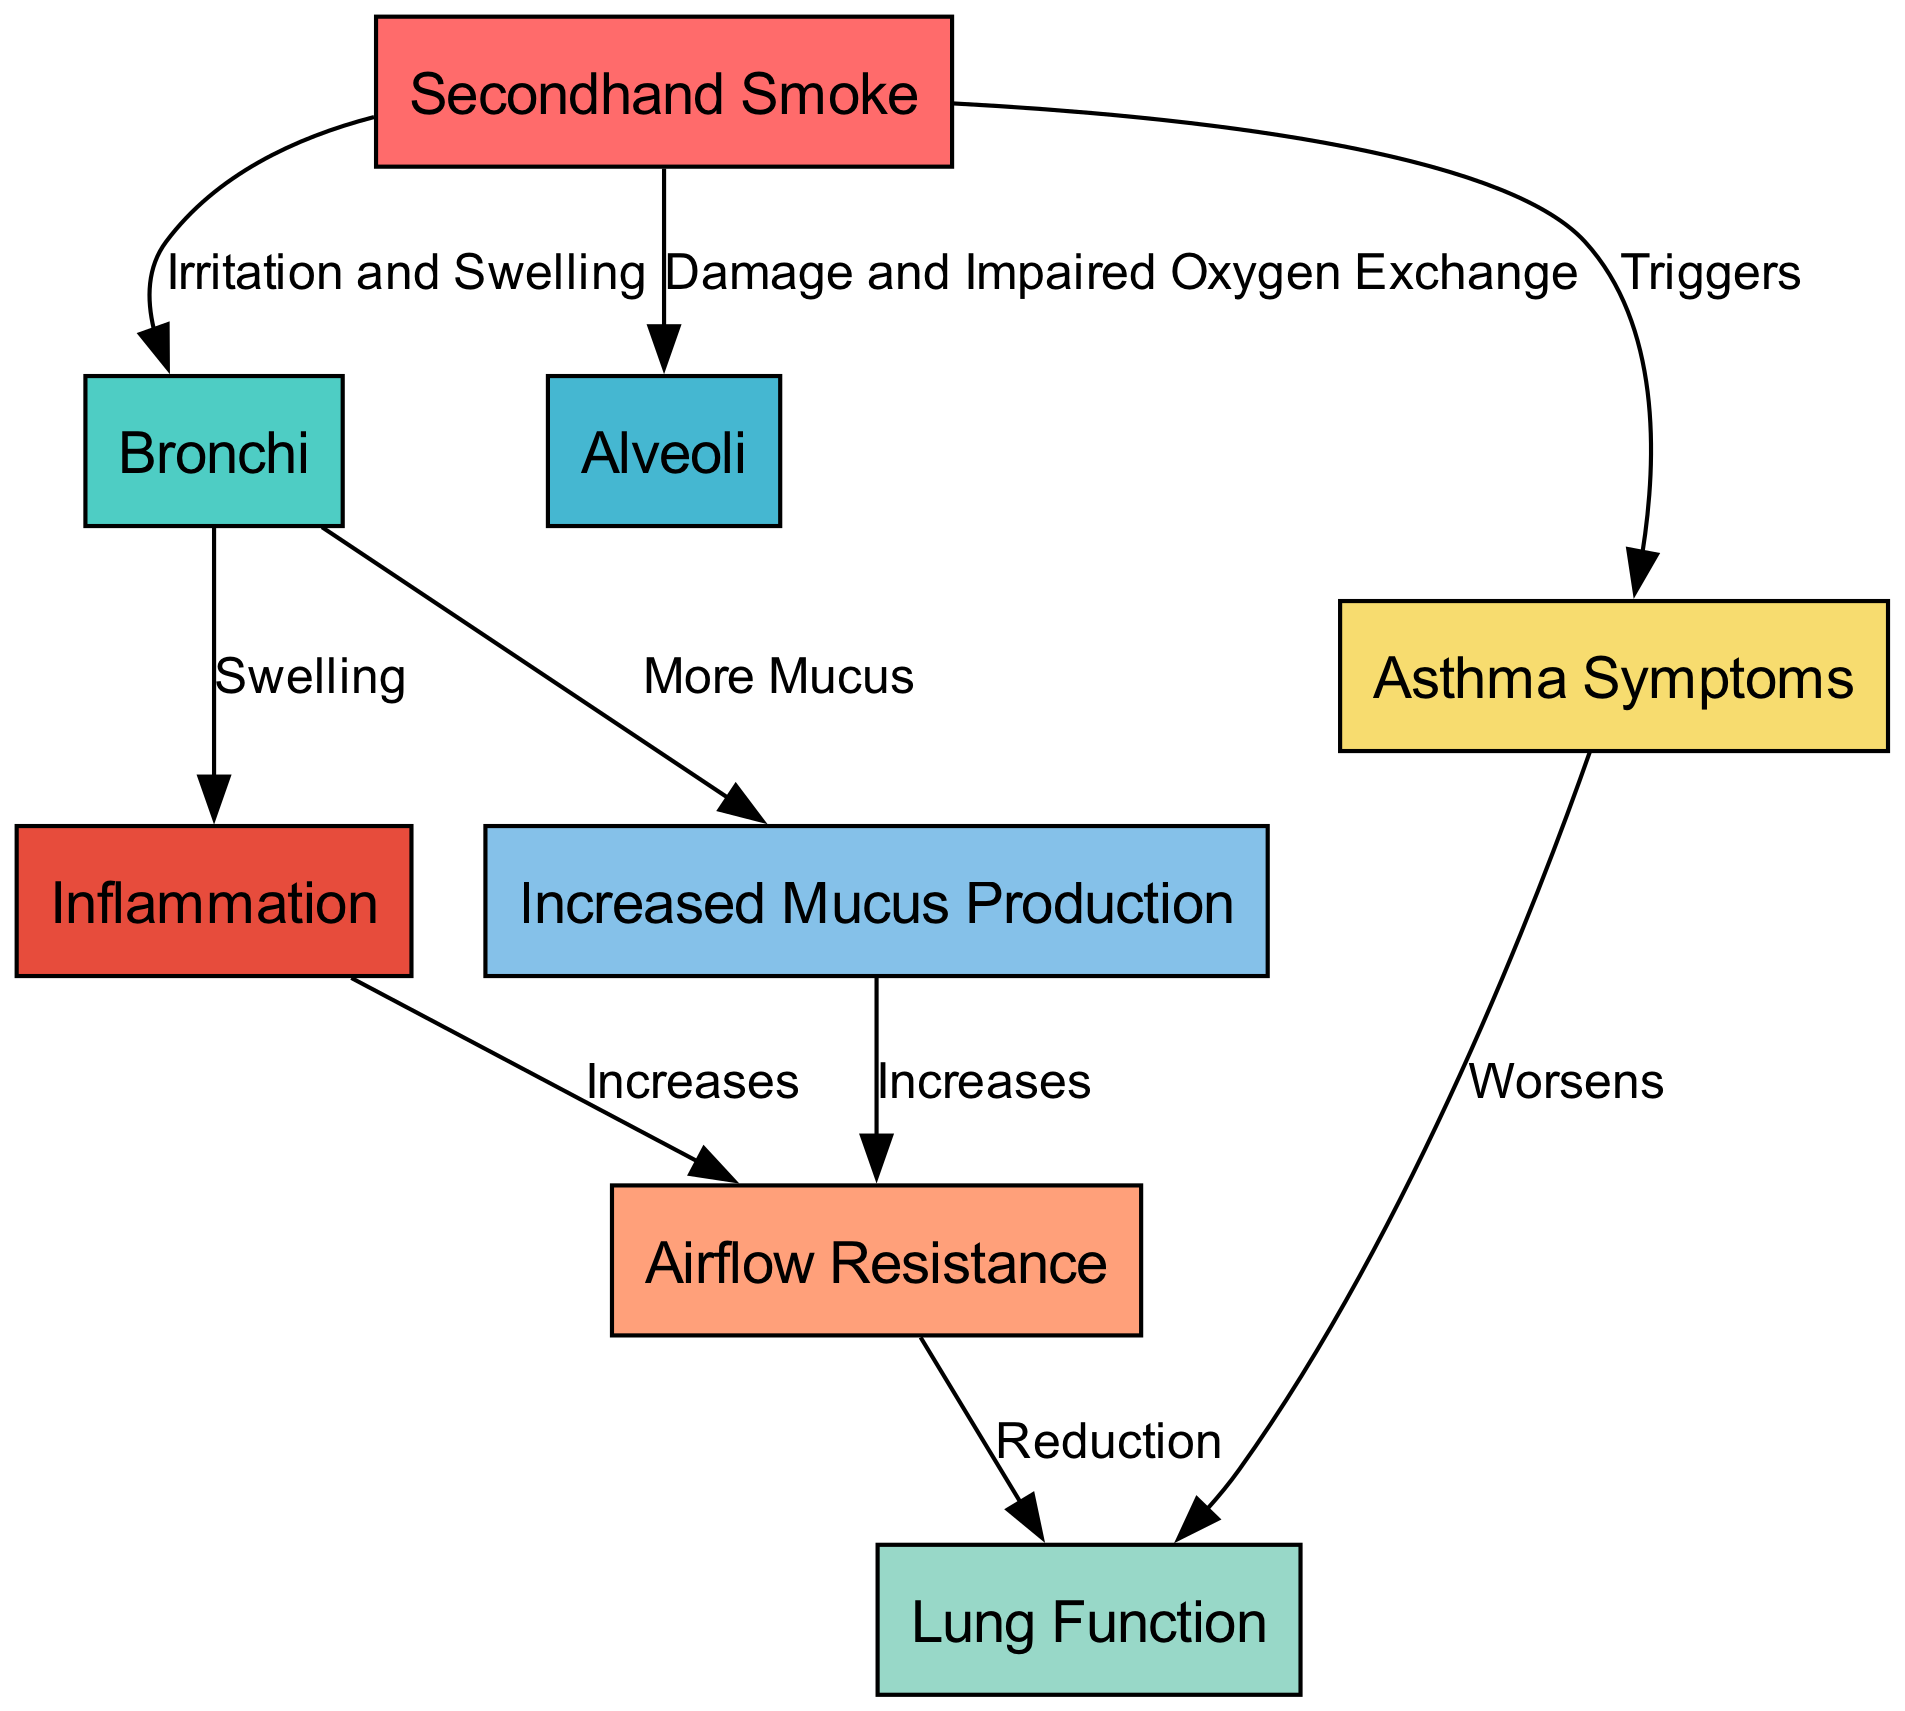What nodes are present in the diagram? The nodes in the diagram include bronchi, alveoli, airflow resistance, secondhand smoke, lung function, asthma symptoms, inflammation, and increased mucus production. Each of these nodes represents key components related to lung function in the context of secondhand smoke.
Answer: bronchi, alveoli, airflow resistance, secondhand smoke, lung function, asthma symptoms, inflammation, increased mucus production How many edges are in the diagram? The diagram contains a total of eight edges representing the relationships between the different nodes. Each edge illustrates how one concept influences another within the context of secondhand smoke exposure.
Answer: 8 What relationship does secondhand smoke have with bronchi? Secondhand smoke irritates and causes swelling in the bronchi, which affects the respiratory system. This relationship indicates the harmful effects of secondhand smoke.
Answer: Irritation and Swelling What is one impact of secondhand smoke on lung function? Exposure to secondhand smoke increases airflow resistance, which leads to a reduction in overall lung function in adolescents, particularly those with asthma. This shows how secondhand smoke contributes to lung problems.
Answer: Reduction How does inflammation impact airflow resistance? Inflammation increases airflow resistance, making it harder for air to flow through the respiratory system. This relationship highlights how an inflammatory response can contribute to breathing difficulties in asthma patients.
Answer: Increases What triggers asthma symptoms according to the diagram? The diagram indicates that secondhand smoke triggers asthma symptoms, illustrating a direct link between exposure to smoke and worsening asthma conditions.
Answer: Triggers How does increased mucus production affect airflow resistance? Increased mucus production results in an increase in airflow resistance, which can make breathing more difficult. This relationship emphasizes the combined effects of mucus buildup and respiratory inflammation.
Answer: Increases What is the overall effect of asthma symptoms on lung function? Asthma symptoms worsen lung function, which indicates that individuals with asthma can experience a decline in their respiratory health, especially when exposed to irritants like secondhand smoke.
Answer: Worsens 